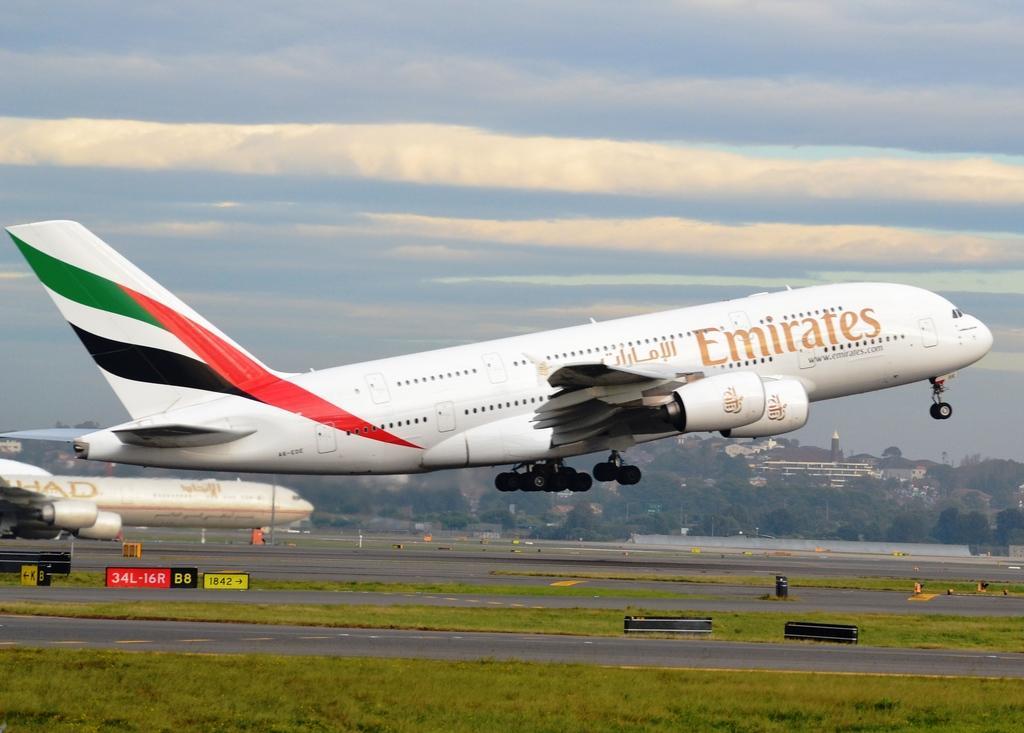Could you give a brief overview of what you see in this image? In this image I can see an aeroplane is taking off, it is in white color. On the left side there is another aeroplane, at the bottom there is the grass and there are trees at the back side of an image, at the top it is the sky. 